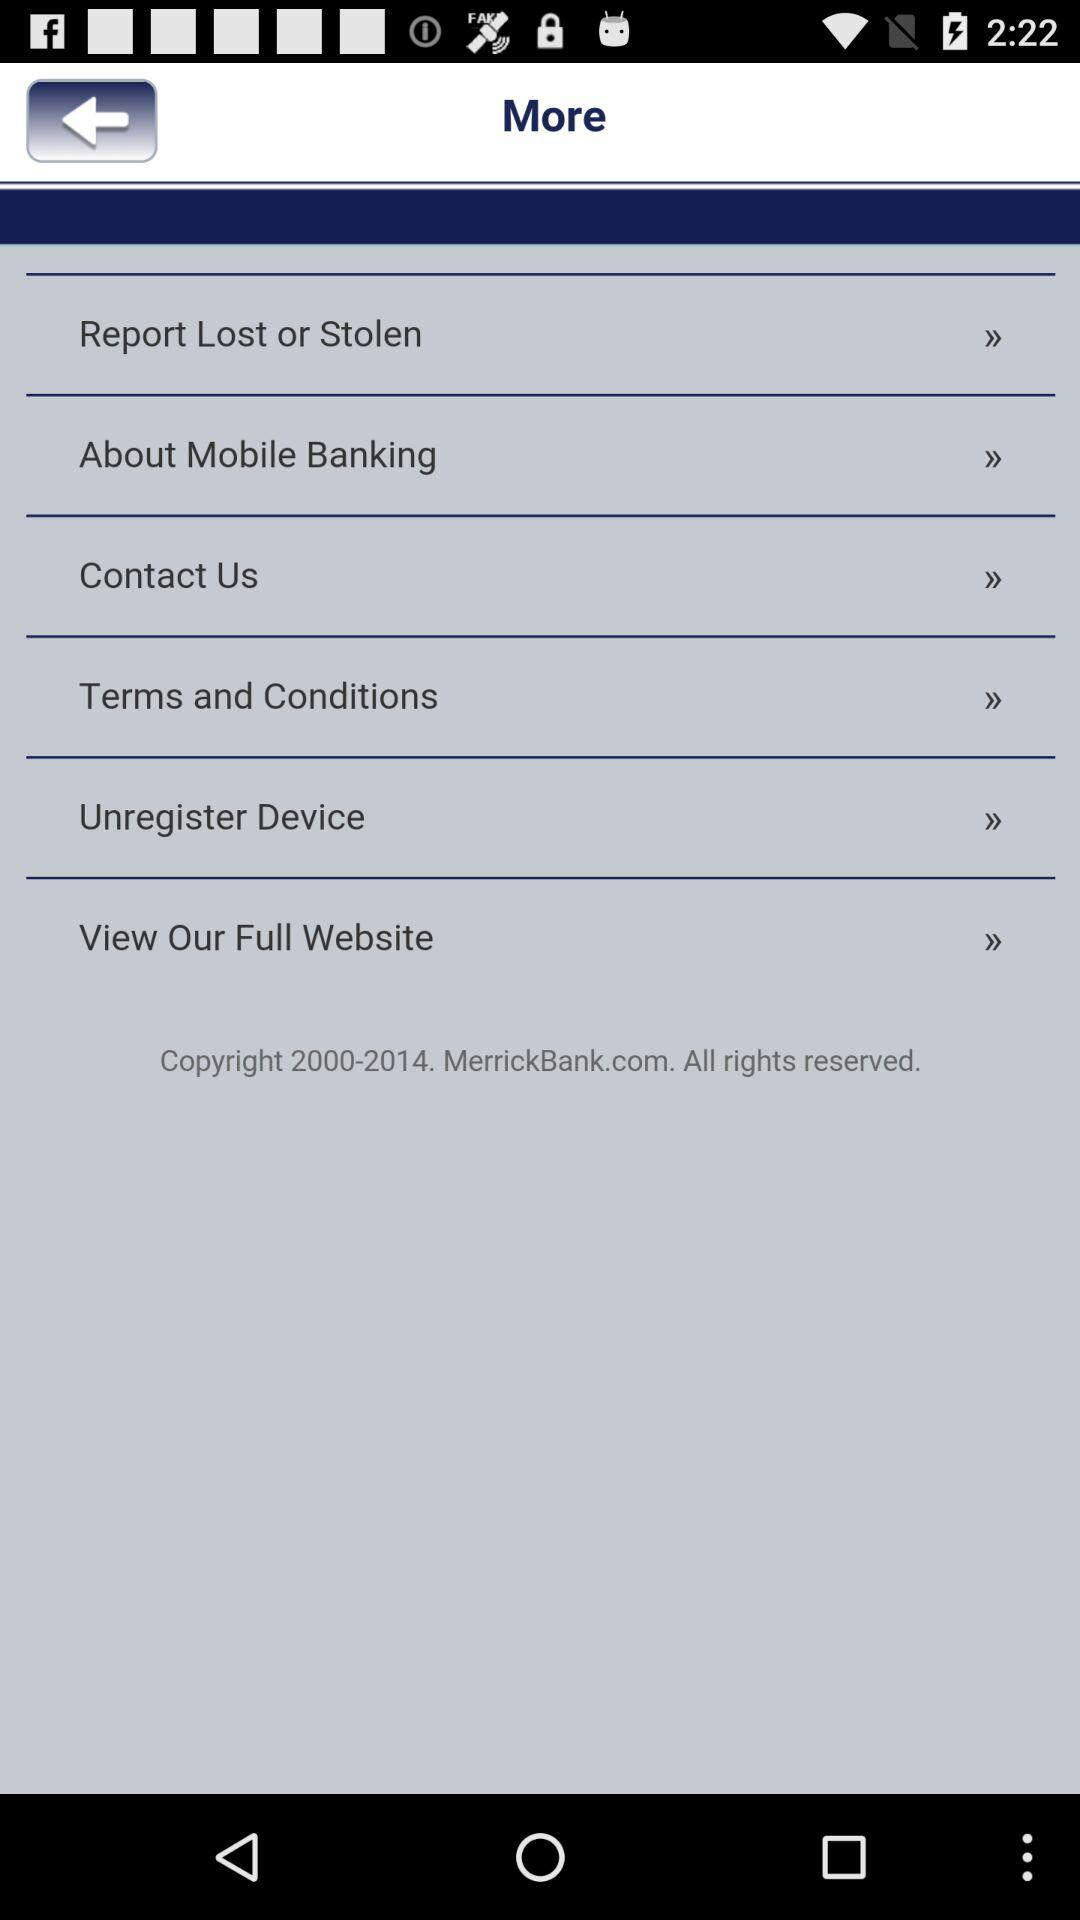How many items have an arrow forward?
Answer the question using a single word or phrase. 6 